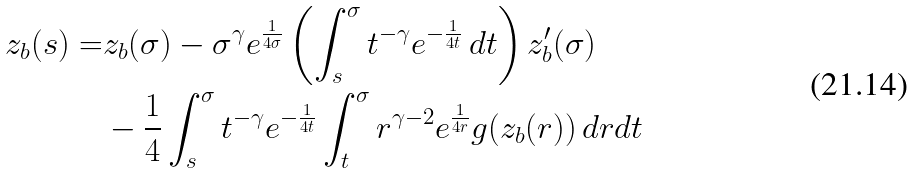Convert formula to latex. <formula><loc_0><loc_0><loc_500><loc_500>z _ { b } ( s ) = & z _ { b } ( \sigma ) - \sigma ^ { \gamma } e ^ { \frac { 1 } { 4 \sigma } } \left ( \int _ { s } ^ { \sigma } t ^ { - \gamma } e ^ { - \frac { 1 } { 4 t } } \, d t \right ) z _ { b } ^ { \prime } ( \sigma ) \\ & - \frac { 1 } { 4 } \int _ { s } ^ { \sigma } t ^ { - \gamma } e ^ { - \frac { 1 } { 4 t } } \int _ { t } ^ { \sigma } r ^ { \gamma - 2 } e ^ { \frac { 1 } { 4 r } } g ( z _ { b } ( r ) ) \, d r d t</formula> 